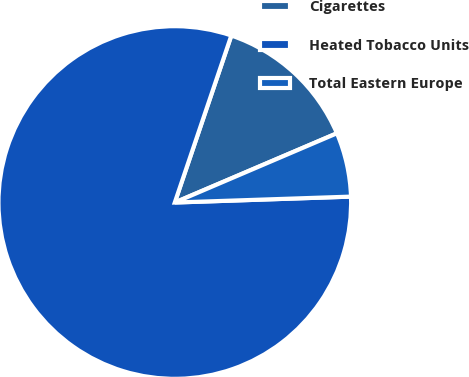Convert chart. <chart><loc_0><loc_0><loc_500><loc_500><pie_chart><fcel>Cigarettes<fcel>Heated Tobacco Units<fcel>Total Eastern Europe<nl><fcel>13.38%<fcel>80.73%<fcel>5.89%<nl></chart> 